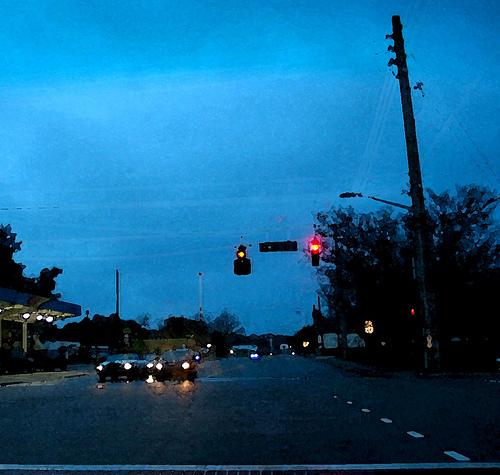How many traffic lights are shown?
Quick response, please. 2. Are there clouds in the sky?
Answer briefly. Yes. How many red lights are there?
Give a very brief answer. 2. How many green lights are there?
Concise answer only. 0. Was this photo taken in the afternoon?
Write a very short answer. No. How many headlights are shown?
Concise answer only. 4. Can you turn left at this intersection?
Give a very brief answer. Yes. What colors are displayed on the traffic lights?
Keep it brief. Red and yellow. 